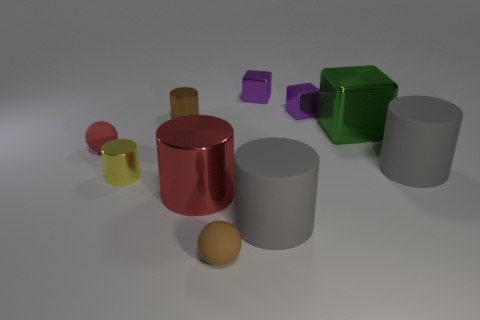Subtract all gray cylinders. How many were subtracted if there are1gray cylinders left? 1 Subtract all tiny purple metallic blocks. How many blocks are left? 1 Subtract all purple cubes. How many cubes are left? 1 Subtract all purple cubes. How many gray cylinders are left? 2 Subtract all cubes. How many objects are left? 7 Subtract all big green spheres. Subtract all large metallic things. How many objects are left? 8 Add 3 big gray cylinders. How many big gray cylinders are left? 5 Add 6 tiny purple objects. How many tiny purple objects exist? 8 Subtract 0 blue cubes. How many objects are left? 10 Subtract 1 spheres. How many spheres are left? 1 